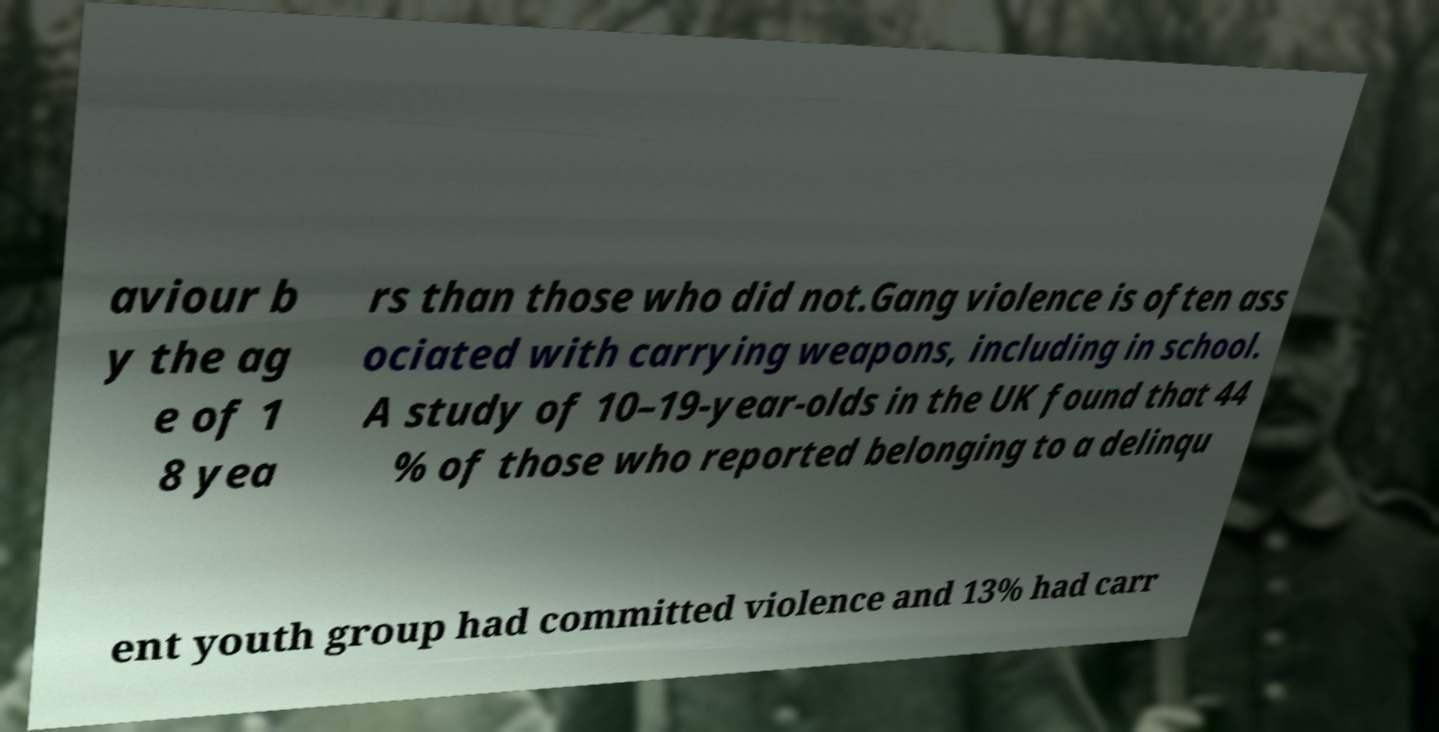For documentation purposes, I need the text within this image transcribed. Could you provide that? aviour b y the ag e of 1 8 yea rs than those who did not.Gang violence is often ass ociated with carrying weapons, including in school. A study of 10–19-year-olds in the UK found that 44 % of those who reported belonging to a delinqu ent youth group had committed violence and 13% had carr 